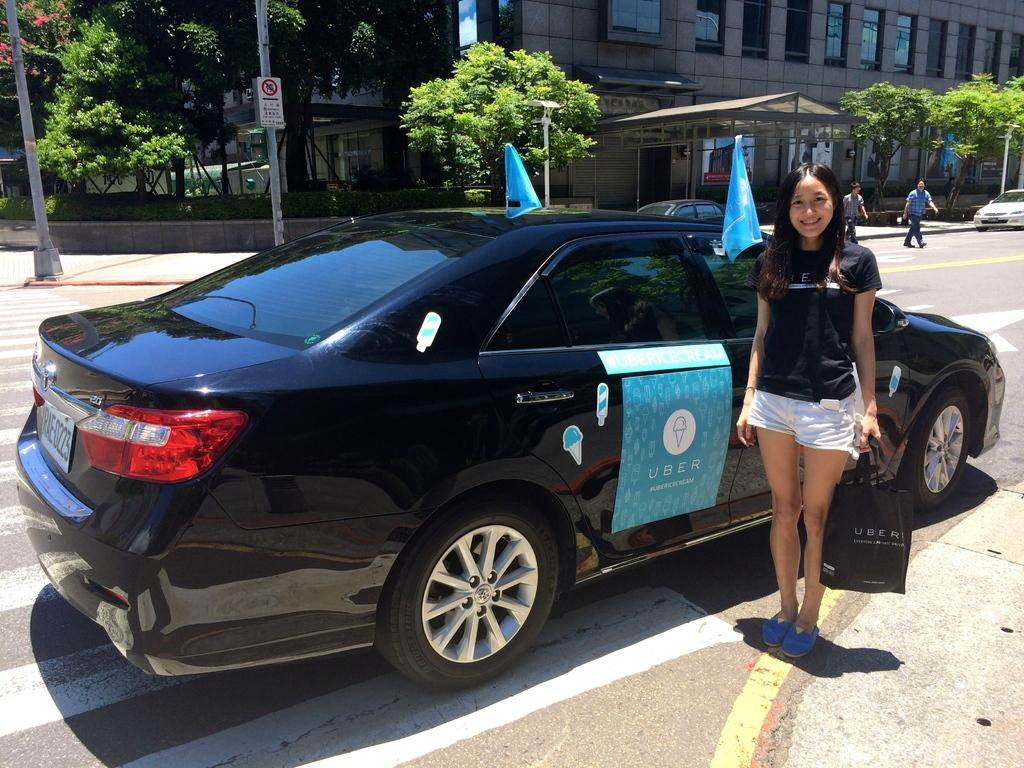What can be seen on the road in the image? There are cars on the road in the image. What is the woman holding in the image? The woman is holding a cover in the image. What can be seen in the background of the image? There are trees, buildings, and current polls visible in the background of the image. What type of drug is the woman using to cover the cars in the image? There is no drug present in the image, and the woman is not using any substance to cover the cars. Can you tell me how many farmers are visible in the image? There are no farmers present in the image. 